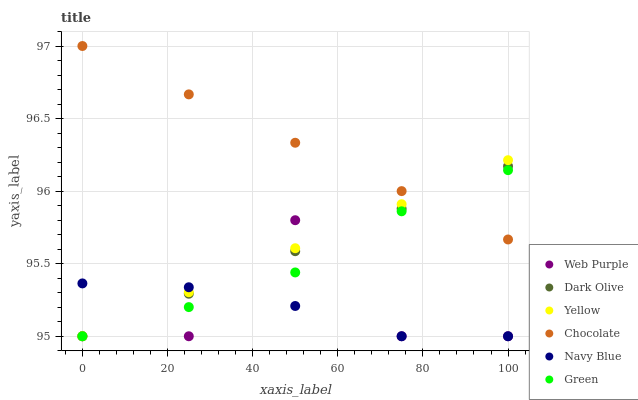Does Navy Blue have the minimum area under the curve?
Answer yes or no. Yes. Does Chocolate have the maximum area under the curve?
Answer yes or no. Yes. Does Dark Olive have the minimum area under the curve?
Answer yes or no. No. Does Dark Olive have the maximum area under the curve?
Answer yes or no. No. Is Dark Olive the smoothest?
Answer yes or no. Yes. Is Web Purple the roughest?
Answer yes or no. Yes. Is Web Purple the smoothest?
Answer yes or no. No. Is Chocolate the roughest?
Answer yes or no. No. Does Navy Blue have the lowest value?
Answer yes or no. Yes. Does Chocolate have the lowest value?
Answer yes or no. No. Does Chocolate have the highest value?
Answer yes or no. Yes. Does Dark Olive have the highest value?
Answer yes or no. No. Is Web Purple less than Chocolate?
Answer yes or no. Yes. Is Chocolate greater than Navy Blue?
Answer yes or no. Yes. Does Web Purple intersect Green?
Answer yes or no. Yes. Is Web Purple less than Green?
Answer yes or no. No. Is Web Purple greater than Green?
Answer yes or no. No. Does Web Purple intersect Chocolate?
Answer yes or no. No. 